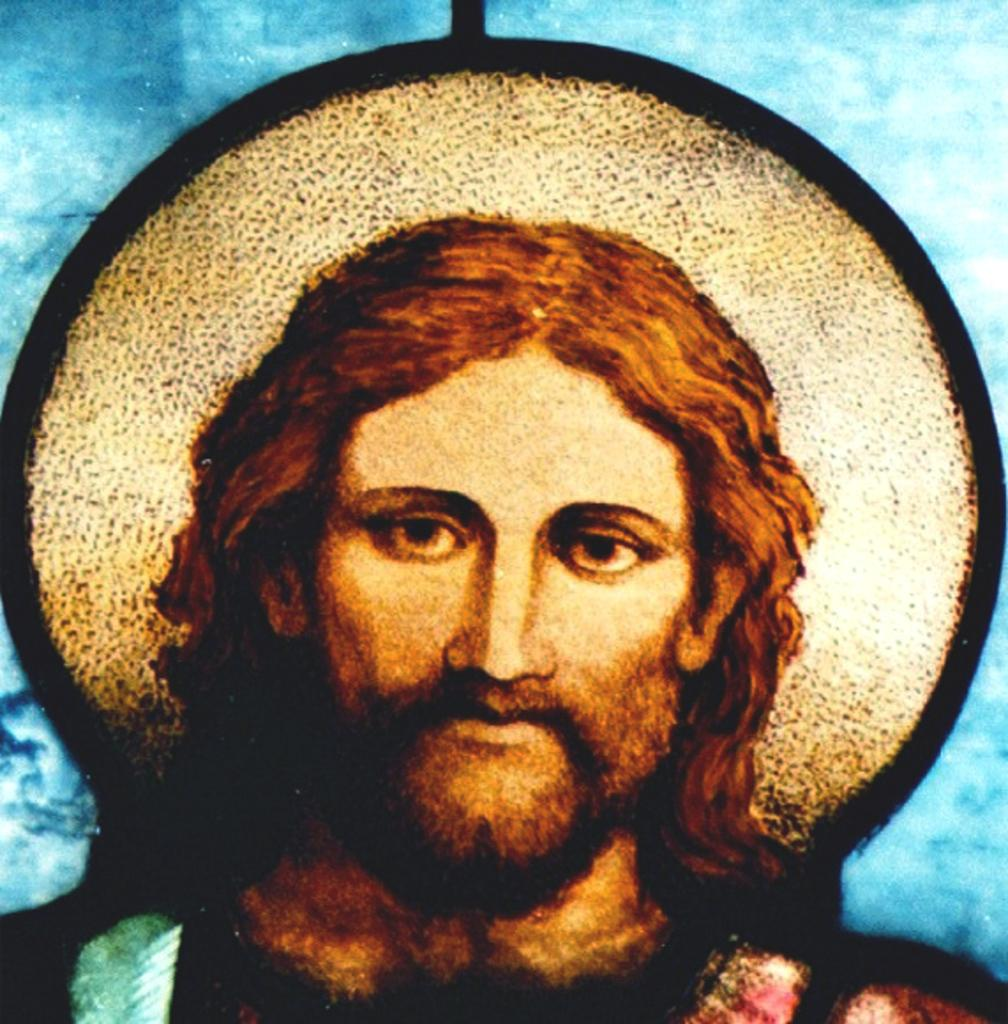What type of image is being described? The image is animated. What is the main subject in the center of the image? There is a statue in the center of the image. What can be seen in the background of the image? There is a wall in the background of the image. What type of oil is being used by the statue in the image? There is no oil mentioned or depicted in the image; it features an animated statue and a wall in the background. 